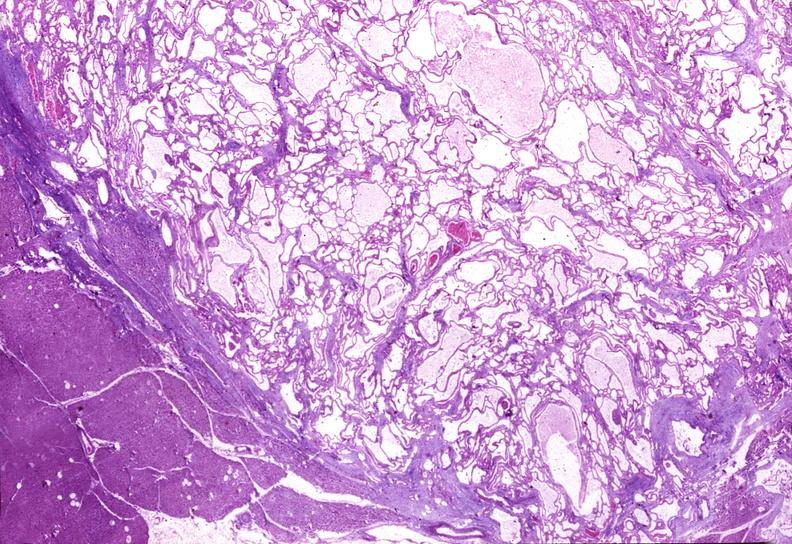s pancreas present?
Answer the question using a single word or phrase. Yes 